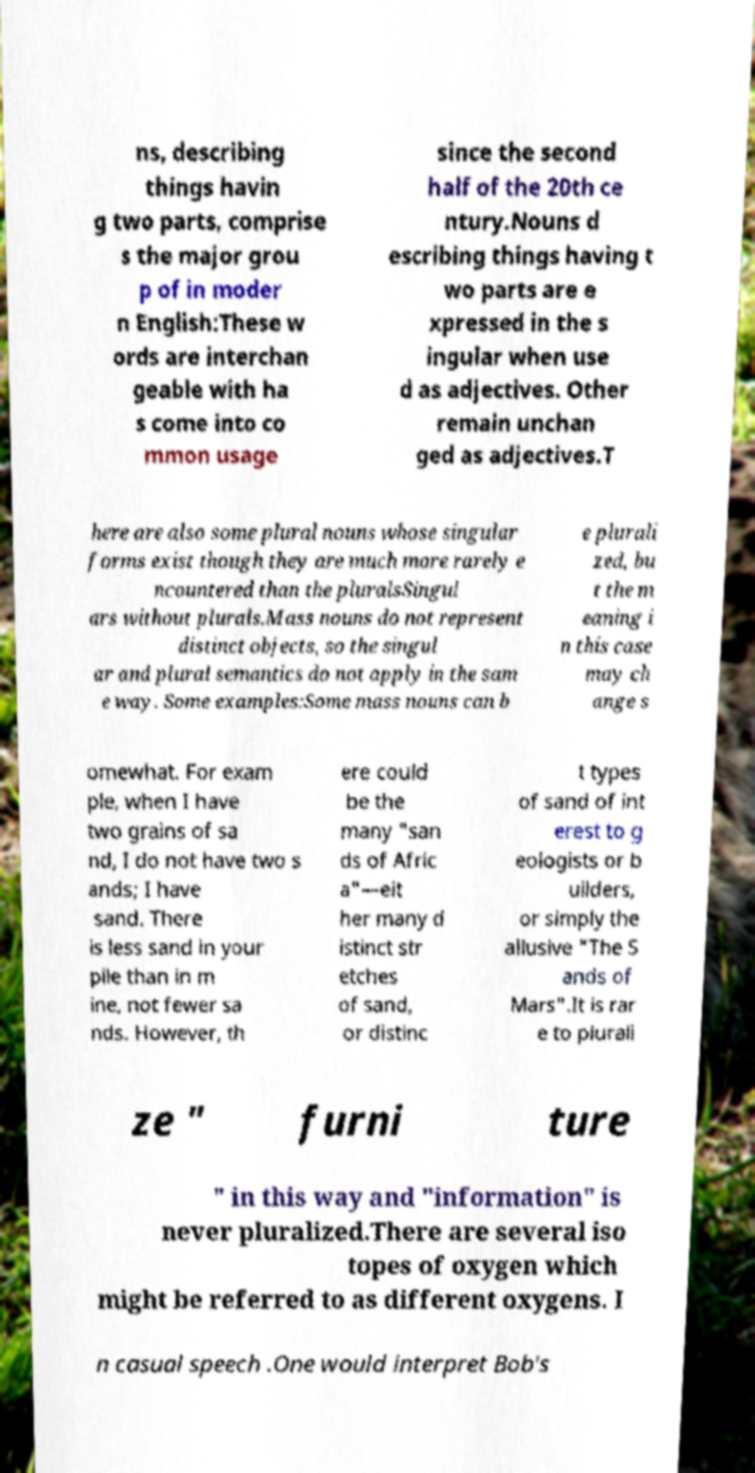Could you extract and type out the text from this image? ns, describing things havin g two parts, comprise s the major grou p of in moder n English:These w ords are interchan geable with ha s come into co mmon usage since the second half of the 20th ce ntury.Nouns d escribing things having t wo parts are e xpressed in the s ingular when use d as adjectives. Other remain unchan ged as adjectives.T here are also some plural nouns whose singular forms exist though they are much more rarely e ncountered than the pluralsSingul ars without plurals.Mass nouns do not represent distinct objects, so the singul ar and plural semantics do not apply in the sam e way. Some examples:Some mass nouns can b e plurali zed, bu t the m eaning i n this case may ch ange s omewhat. For exam ple, when I have two grains of sa nd, I do not have two s ands; I have sand. There is less sand in your pile than in m ine, not fewer sa nds. However, th ere could be the many "san ds of Afric a"—eit her many d istinct str etches of sand, or distinc t types of sand of int erest to g eologists or b uilders, or simply the allusive "The S ands of Mars".It is rar e to plurali ze " furni ture " in this way and "information" is never pluralized.There are several iso topes of oxygen which might be referred to as different oxygens. I n casual speech .One would interpret Bob's 